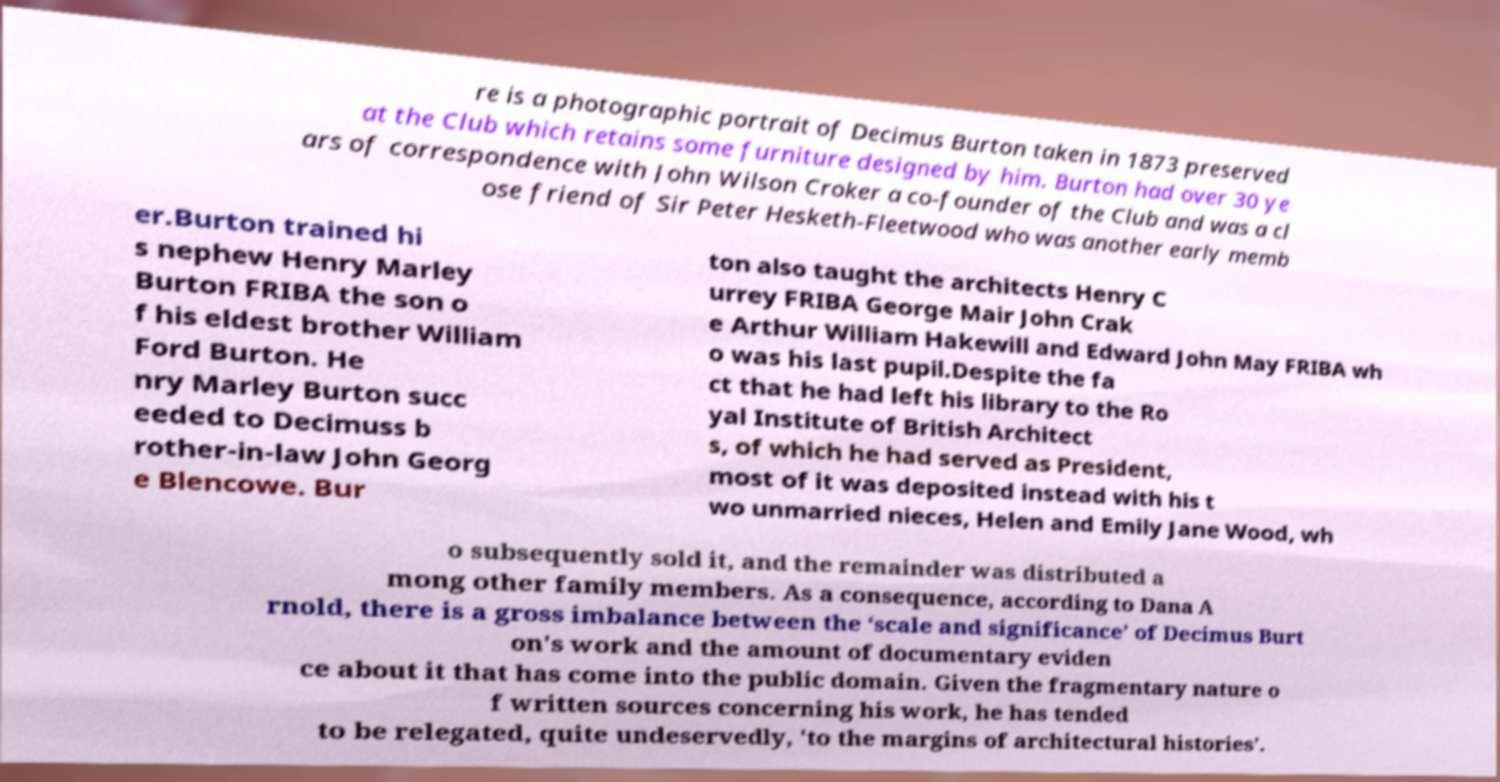Could you extract and type out the text from this image? re is a photographic portrait of Decimus Burton taken in 1873 preserved at the Club which retains some furniture designed by him. Burton had over 30 ye ars of correspondence with John Wilson Croker a co-founder of the Club and was a cl ose friend of Sir Peter Hesketh-Fleetwood who was another early memb er.Burton trained hi s nephew Henry Marley Burton FRIBA the son o f his eldest brother William Ford Burton. He nry Marley Burton succ eeded to Decimuss b rother-in-law John Georg e Blencowe. Bur ton also taught the architects Henry C urrey FRIBA George Mair John Crak e Arthur William Hakewill and Edward John May FRIBA wh o was his last pupil.Despite the fa ct that he had left his library to the Ro yal Institute of British Architect s, of which he had served as President, most of it was deposited instead with his t wo unmarried nieces, Helen and Emily Jane Wood, wh o subsequently sold it, and the remainder was distributed a mong other family members. As a consequence, according to Dana A rnold, there is a gross imbalance between the ‘scale and significance’ of Decimus Burt on's work and the amount of documentary eviden ce about it that has come into the public domain. Given the fragmentary nature o f written sources concerning his work, he has tended to be relegated, quite undeservedly, 'to the margins of architectural histories’. 